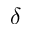<formula> <loc_0><loc_0><loc_500><loc_500>\delta</formula> 